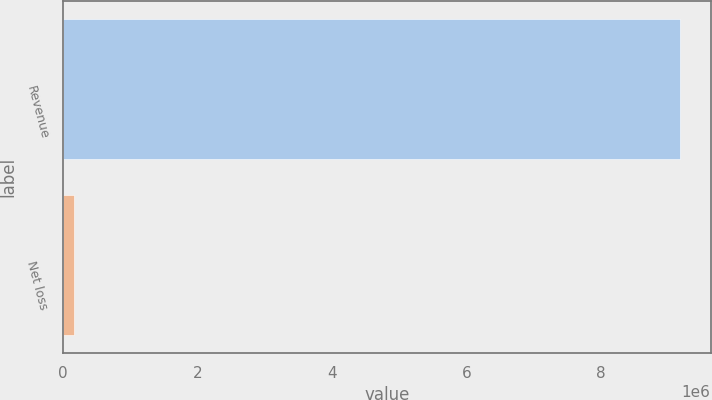<chart> <loc_0><loc_0><loc_500><loc_500><bar_chart><fcel>Revenue<fcel>Net loss<nl><fcel>9.16982e+06<fcel>156188<nl></chart> 